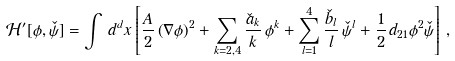Convert formula to latex. <formula><loc_0><loc_0><loc_500><loc_500>\mathcal { H } ^ { \prime } [ \phi , \check { \psi } ] = \int \, d ^ { d } x \left [ \frac { A } { 2 } \left ( \nabla \phi \right ) ^ { 2 } + \sum _ { k = 2 , 4 } \frac { \check { a } _ { k } } { k } \, { \phi } ^ { k } + \sum _ { l = 1 } ^ { 4 } \frac { \check { b } _ { l } } { l } \, { \check { \psi } } ^ { l } + \frac { 1 } { 2 } \, d _ { 2 1 } { \phi } ^ { 2 } \check { \psi } \right ] \, ,</formula> 